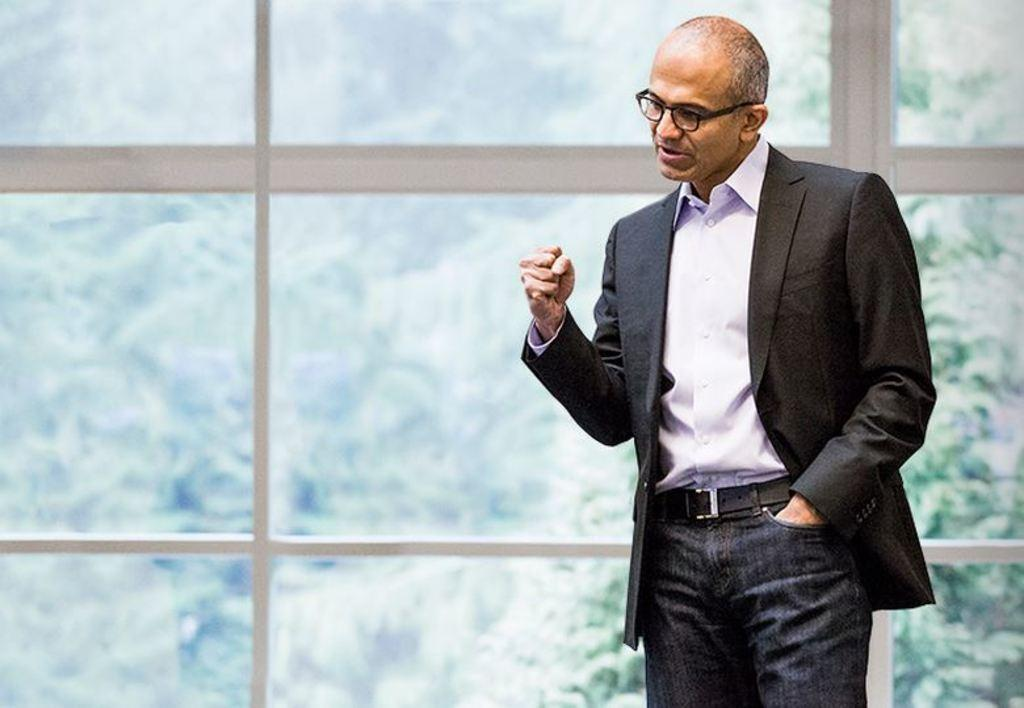What is the person in the image wearing? The person is wearing a white and black color dress. What can be seen in the background of the image? There is a glass wall and trees visible in the background of the image. How many dolls are sitting on the jelly in the image? There are no dolls or jelly present in the image. 